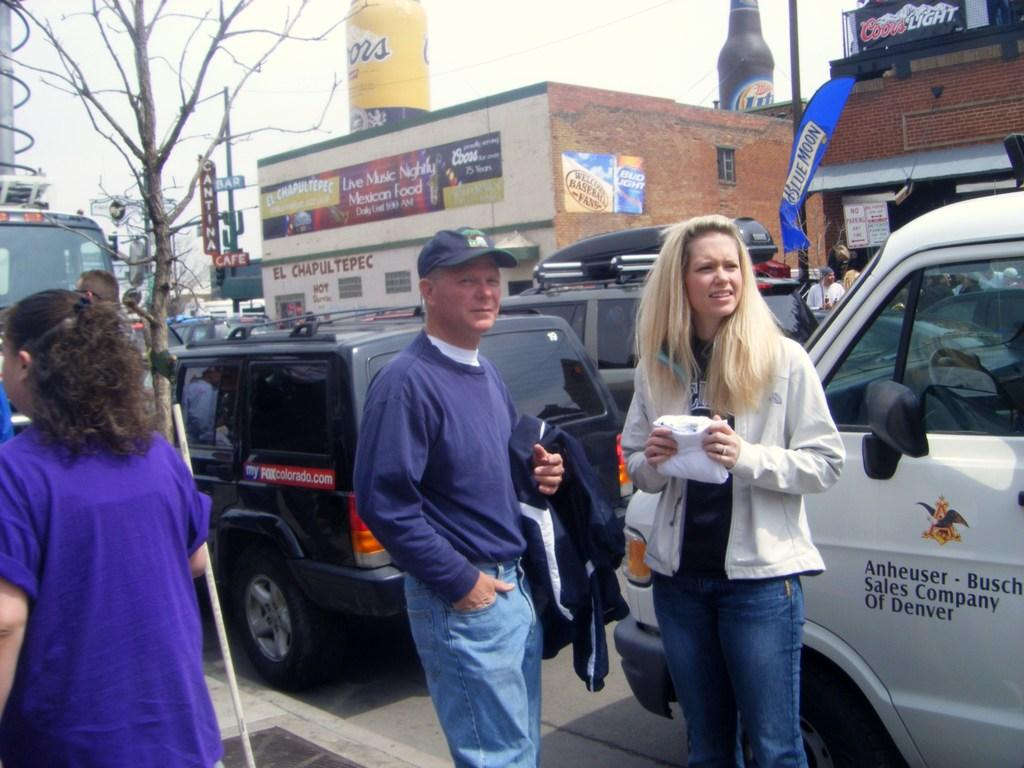<image>
Render a clear and concise summary of the photo. A large, inflatable Coors and Miller Lite beer bottle are on top a building, across the street from several parked cars, and people walking on the sidewalk. 